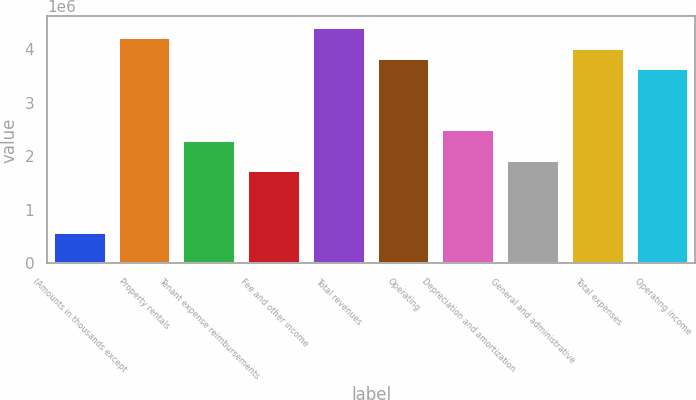Convert chart. <chart><loc_0><loc_0><loc_500><loc_500><bar_chart><fcel>(Amounts in thousands except<fcel>Property rentals<fcel>Tenant expense reimbursements<fcel>Fee and other income<fcel>Total revenues<fcel>Operating<fcel>Depreciation and amortization<fcel>General and administrative<fcel>Total expenses<fcel>Operating income<nl><fcel>572730<fcel>4.20002e+06<fcel>2.29092e+06<fcel>1.71819e+06<fcel>4.39093e+06<fcel>3.8182e+06<fcel>2.48183e+06<fcel>1.9091e+06<fcel>4.00911e+06<fcel>3.62729e+06<nl></chart> 